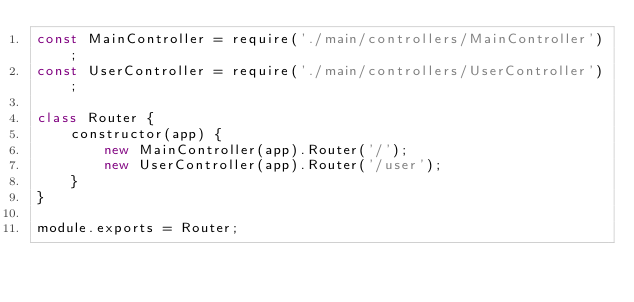Convert code to text. <code><loc_0><loc_0><loc_500><loc_500><_JavaScript_>const MainController = require('./main/controllers/MainController');
const UserController = require('./main/controllers/UserController');

class Router {
    constructor(app) {
        new MainController(app).Router('/');
        new UserController(app).Router('/user');
    }
}

module.exports = Router;
</code> 